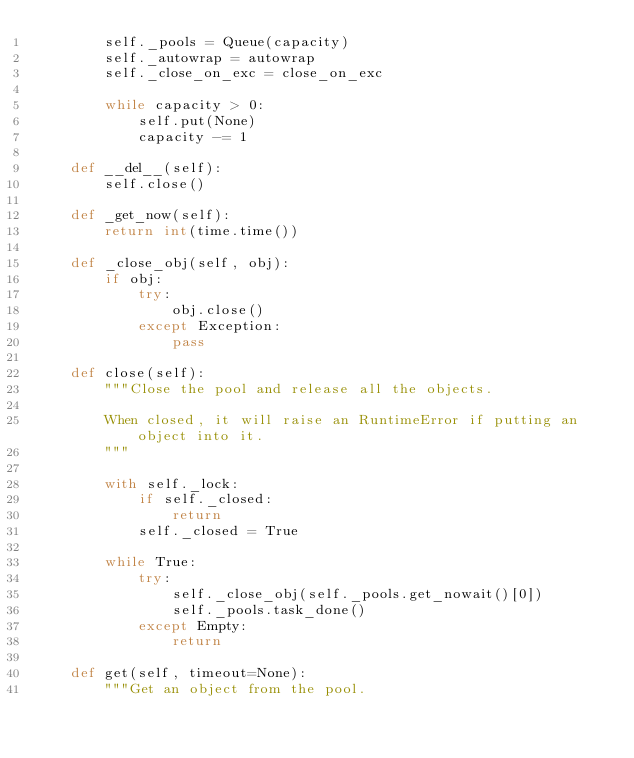Convert code to text. <code><loc_0><loc_0><loc_500><loc_500><_Python_>        self._pools = Queue(capacity)
        self._autowrap = autowrap
        self._close_on_exc = close_on_exc

        while capacity > 0:
            self.put(None)
            capacity -= 1

    def __del__(self):
        self.close()

    def _get_now(self):
        return int(time.time())

    def _close_obj(self, obj):
        if obj:
            try:
                obj.close()
            except Exception:
                pass

    def close(self):
        """Close the pool and release all the objects.

        When closed, it will raise an RuntimeError if putting an object into it.
        """

        with self._lock:
            if self._closed:
                return
            self._closed = True

        while True:
            try:
                self._close_obj(self._pools.get_nowait()[0])
                self._pools.task_done()
            except Empty:
                return

    def get(self, timeout=None):
        """Get an object from the pool.
</code> 